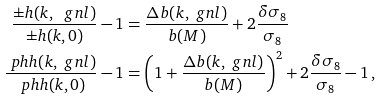<formula> <loc_0><loc_0><loc_500><loc_500>\frac { \pm h ( k , \ g n l ) } { \pm h ( k , 0 ) } - 1 & = \frac { \Delta b ( k , \ g n l ) } { b ( M ) } + 2 \frac { \delta \sigma _ { 8 } } { \sigma _ { 8 } } \\ \frac { \ p h h ( k , \ g n l ) } { \ p h h ( k , 0 ) } - 1 & = \left ( 1 + \frac { \Delta b ( k , \ g n l ) } { b ( M ) } \right ) ^ { 2 } + 2 \frac { \delta \sigma _ { 8 } } { \sigma _ { 8 } } - 1 \, ,</formula> 